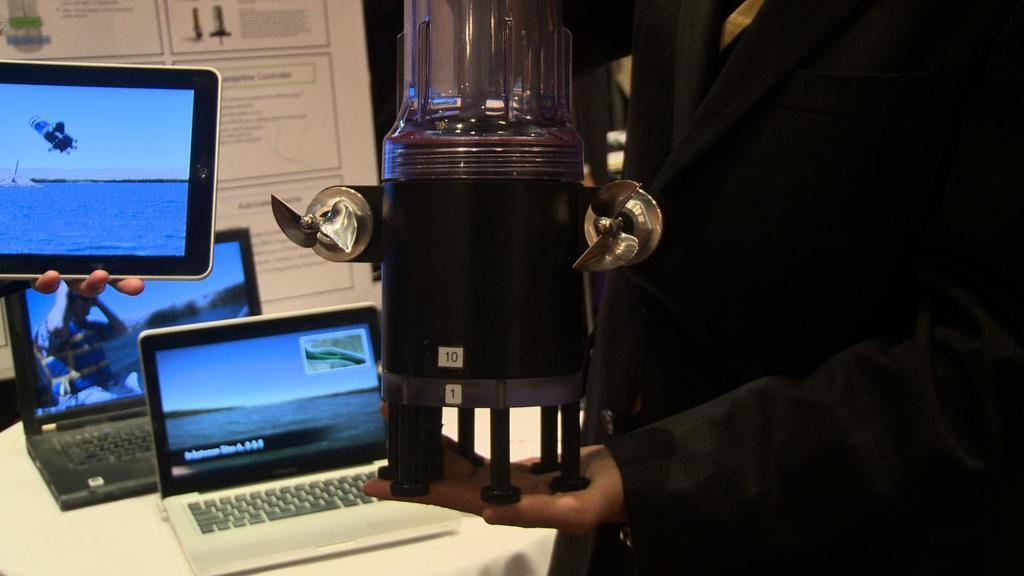<image>
Offer a succinct explanation of the picture presented. A man holding a strange object with the numbers 10 and 1 on the front of it. 